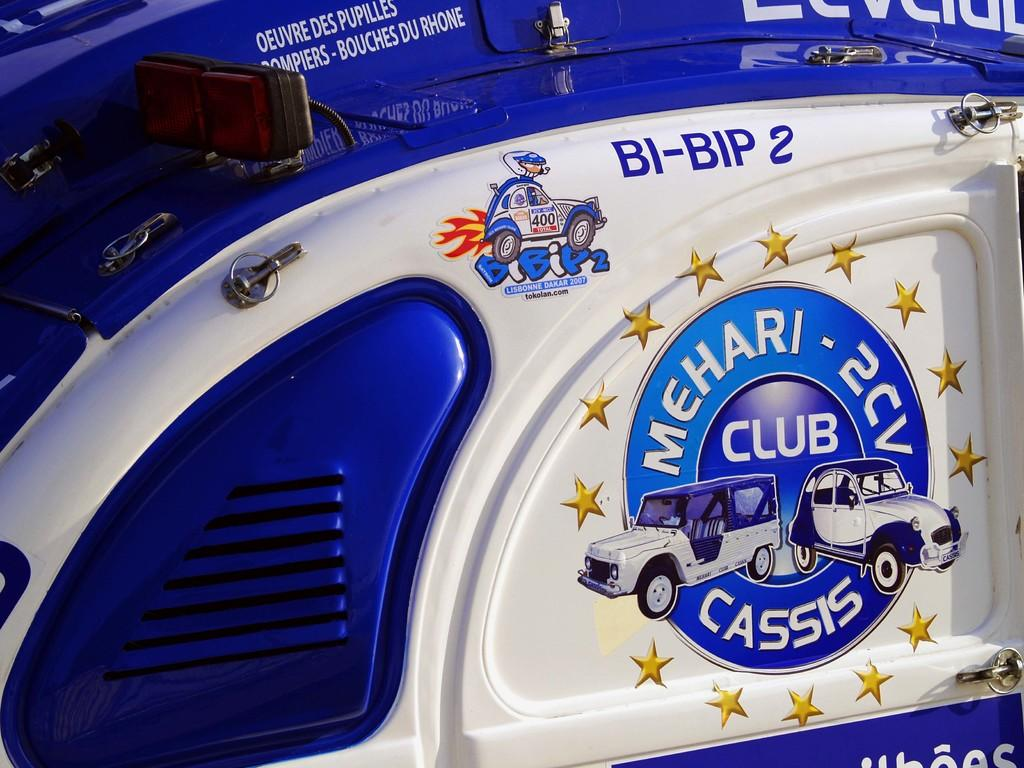What is the color of the object in the image? The object in the image is blue and white. What is depicted on the object? The object has pictures of cars on it. What type of farm animals can be seen in the image? There are no farm animals present in the image; it features a blue and white object with pictures of cars on it. What story is being told in the image? There is no story being told in the image; it simply shows a blue and white object with pictures of cars on it. 